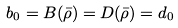Convert formula to latex. <formula><loc_0><loc_0><loc_500><loc_500>b _ { 0 } = B ( \bar { \rho } ) = D ( \bar { \rho } ) = d _ { 0 }</formula> 